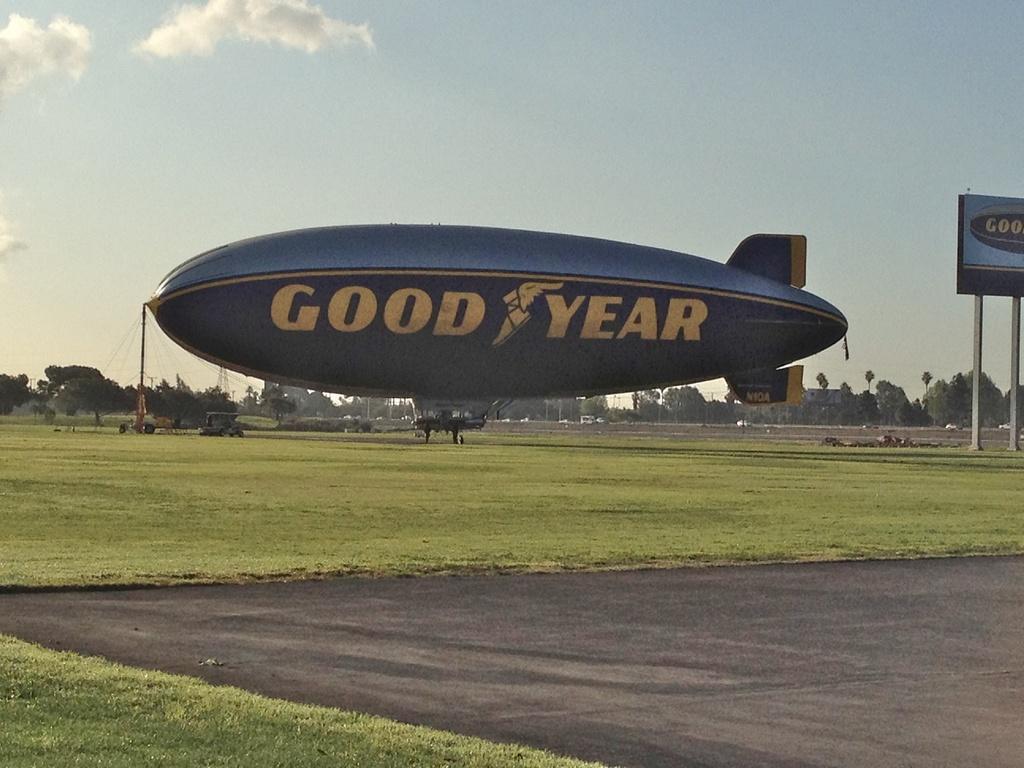Can you describe this image briefly? In this image we can see advertisements on the ground, motor vehicles, poles, towers, trees and sky with clouds. 